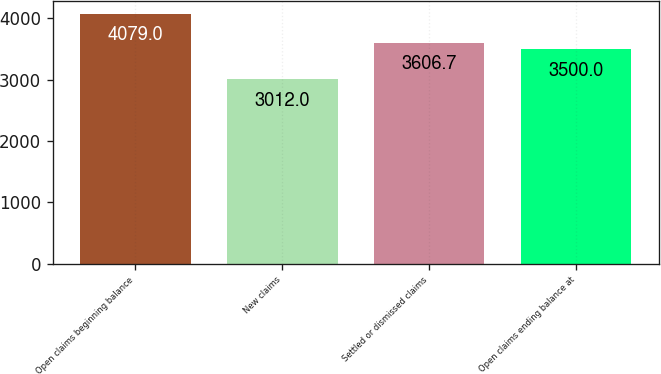Convert chart. <chart><loc_0><loc_0><loc_500><loc_500><bar_chart><fcel>Open claims beginning balance<fcel>New claims<fcel>Settled or dismissed claims<fcel>Open claims ending balance at<nl><fcel>4079<fcel>3012<fcel>3606.7<fcel>3500<nl></chart> 